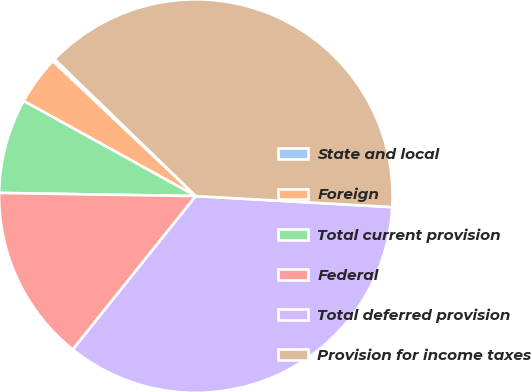Convert chart. <chart><loc_0><loc_0><loc_500><loc_500><pie_chart><fcel>State and local<fcel>Foreign<fcel>Total current provision<fcel>Federal<fcel>Total deferred provision<fcel>Provision for income taxes<nl><fcel>0.22%<fcel>4.0%<fcel>7.78%<fcel>14.5%<fcel>34.86%<fcel>38.64%<nl></chart> 